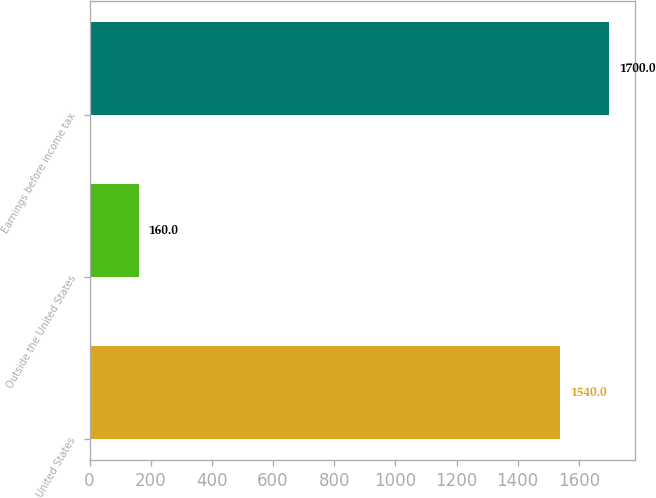<chart> <loc_0><loc_0><loc_500><loc_500><bar_chart><fcel>United States<fcel>Outside the United States<fcel>Earnings before income tax<nl><fcel>1540<fcel>160<fcel>1700<nl></chart> 